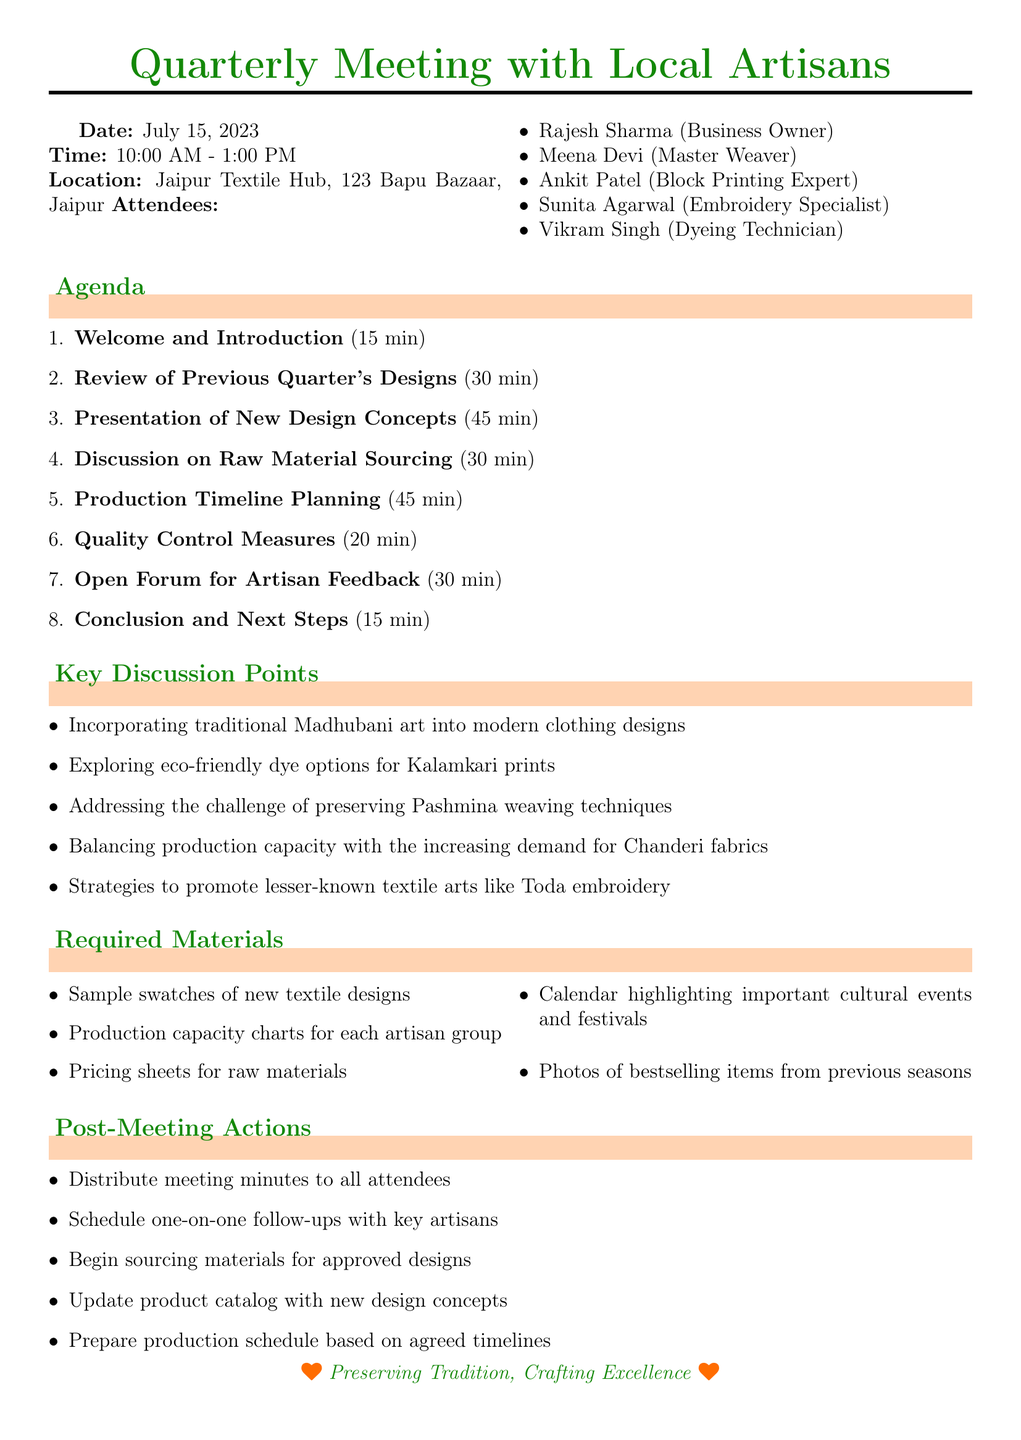What is the date of the meeting? The date of the meeting is explicitly stated in the document as July 15, 2023.
Answer: July 15, 2023 How long is the session on "Production Timeline Planning"? The duration for "Production Timeline Planning" is noted in the agenda section of the document.
Answer: 45 minutes Who is the embroidery specialist attending the meeting? The document lists attendees and specifies Sunita Agarwal as the Embroidery Specialist.
Answer: Sunita Agarwal What are the key discussion points related to textile arts? The document provides a list of key discussion points that focus on various textile arts.
Answer: Traditional Madhubani art, eco-friendly dye options, preserving Pashmina weaving, production capacity for Chanderi fabrics, Toda embroidery How many attendees are there in total? The document lists all attendees, which can be counted for the total number.
Answer: 5 What is one of the required materials for the meeting? The document enumerates required materials necessary for discussion during the meeting.
Answer: Sample swatches of new textile designs What follows after the meeting according to the action items? The document specifies actions that need to be taken after the meeting concludes.
Answer: Distribute meeting minutes to all attendees 